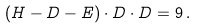Convert formula to latex. <formula><loc_0><loc_0><loc_500><loc_500>( H - D - E ) \cdot D \cdot D = 9 \, .</formula> 